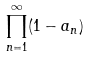Convert formula to latex. <formula><loc_0><loc_0><loc_500><loc_500>\prod _ { n = 1 } ^ { \infty } ( 1 - a _ { n } )</formula> 